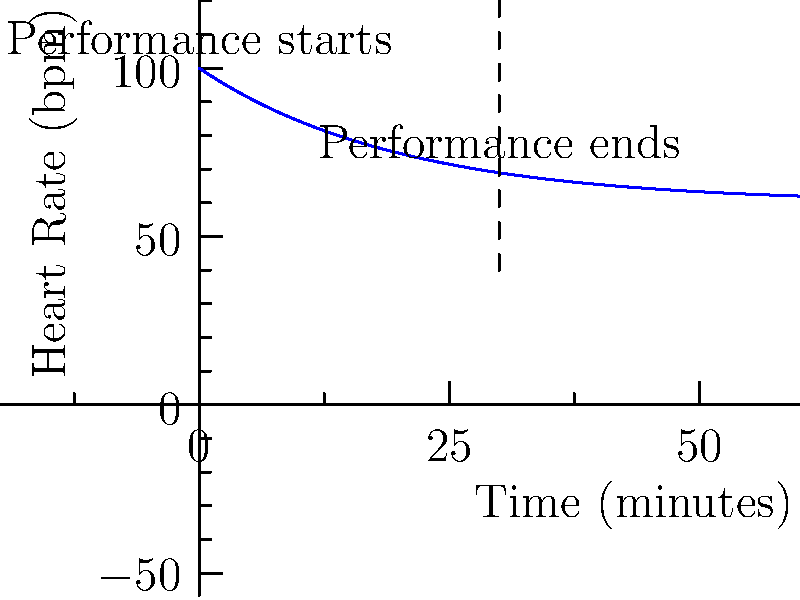The graph shows the heart rate of a pianist during a 60-minute period, including a 30-minute performance. What physiological effect does performance anxiety have on the pianist's heart rate, and how does it change over time? To answer this question, let's analyze the graph step-by-step:

1. Initial heart rate: At time 0, the pianist's heart rate is at its highest point, approximately 100 beats per minute (bpm).

2. Performance anxiety effect: The elevated heart rate at the beginning indicates that performance anxiety has caused an increase in the pianist's heart rate above the normal resting rate (typically 60-100 bpm for adults).

3. Heart rate pattern during performance:
   - From 0 to 30 minutes (during the performance), we see a gradual decrease in heart rate.
   - This decrease follows an exponential decay pattern, suggesting that the anxiety effect diminishes over time.

4. Post-performance heart rate:
   - After the 30-minute mark (end of performance), the heart rate continues to decrease but at a slower rate.
   - By the 60-minute mark, the heart rate has nearly stabilized, approaching what could be the pianist's normal resting heart rate.

5. Physiological explanation:
   - The initial spike in heart rate is due to the sympathetic nervous system's "fight or flight" response triggered by performance anxiety.
   - As the pianist becomes more comfortable during the performance, the parasympathetic nervous system gradually takes over, lowering the heart rate.

In summary, performance anxiety causes an initial elevation in heart rate, which then gradually decreases during and after the performance as the body's stress response subsides.
Answer: Performance anxiety initially elevates heart rate, which then gradually decreases during and after the performance. 